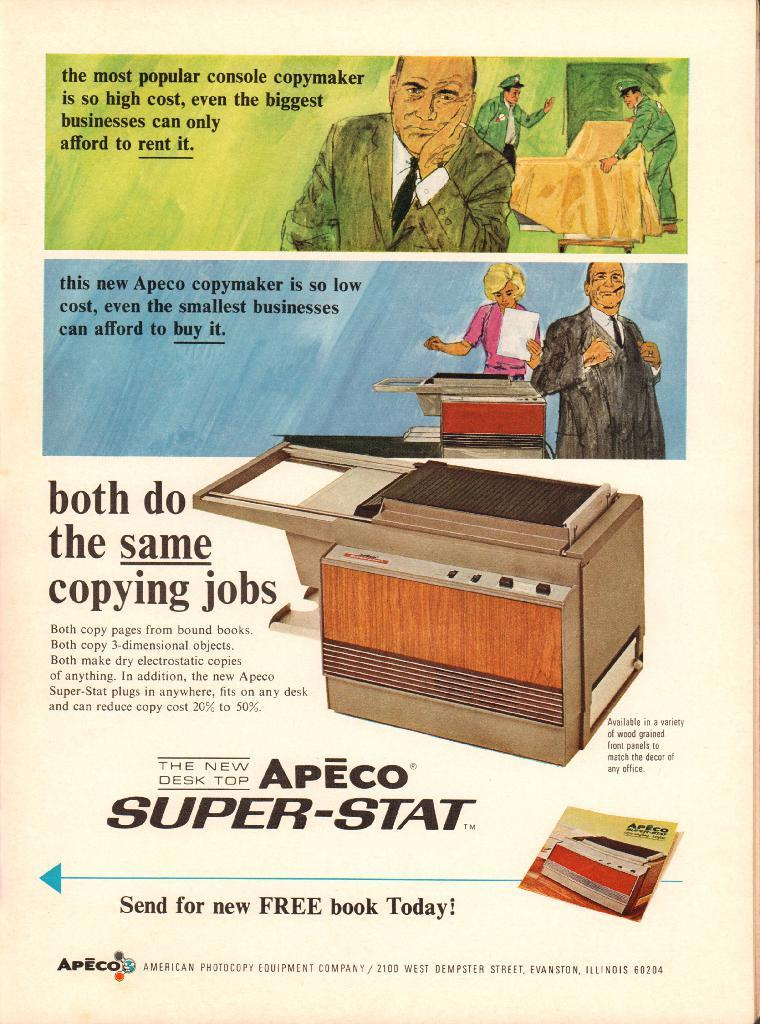<image>
Give a short and clear explanation of the subsequent image. an old ad for Apeco Super Stat for a copy maker 